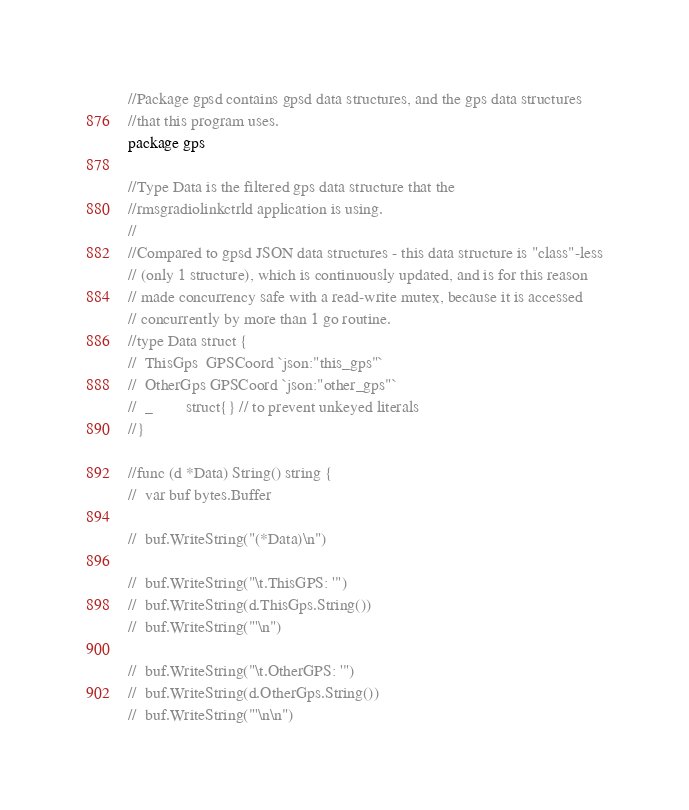Convert code to text. <code><loc_0><loc_0><loc_500><loc_500><_Go_>//Package gpsd contains gpsd data structures, and the gps data structures
//that this program uses.
package gps

//Type Data is the filtered gps data structure that the
//rmsgradiolinkctrld application is using.
//
//Compared to gpsd JSON data structures - this data structure is "class"-less
// (only 1 structure), which is continuously updated, and is for this reason
// made concurrency safe with a read-write mutex, because it is accessed
// concurrently by more than 1 go routine.
//type Data struct {
//	ThisGps  GPSCoord `json:"this_gps"`
//	OtherGps GPSCoord `json:"other_gps"`
//	_        struct{} // to prevent unkeyed literals
//}

//func (d *Data) String() string {
//	var buf bytes.Buffer

//	buf.WriteString("(*Data)\n")

//	buf.WriteString("\t.ThisGPS: '")
//	buf.WriteString(d.ThisGps.String())
//	buf.WriteString("'\n")

//	buf.WriteString("\t.OtherGPS: '")
//	buf.WriteString(d.OtherGps.String())
//	buf.WriteString("'\n\n")
</code> 